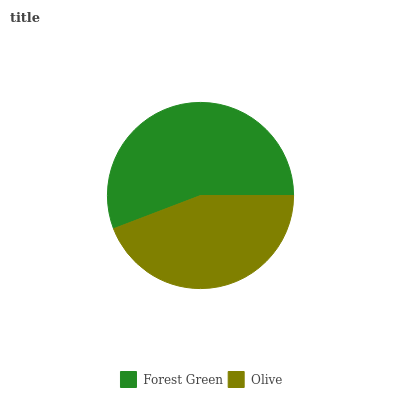Is Olive the minimum?
Answer yes or no. Yes. Is Forest Green the maximum?
Answer yes or no. Yes. Is Olive the maximum?
Answer yes or no. No. Is Forest Green greater than Olive?
Answer yes or no. Yes. Is Olive less than Forest Green?
Answer yes or no. Yes. Is Olive greater than Forest Green?
Answer yes or no. No. Is Forest Green less than Olive?
Answer yes or no. No. Is Forest Green the high median?
Answer yes or no. Yes. Is Olive the low median?
Answer yes or no. Yes. Is Olive the high median?
Answer yes or no. No. Is Forest Green the low median?
Answer yes or no. No. 